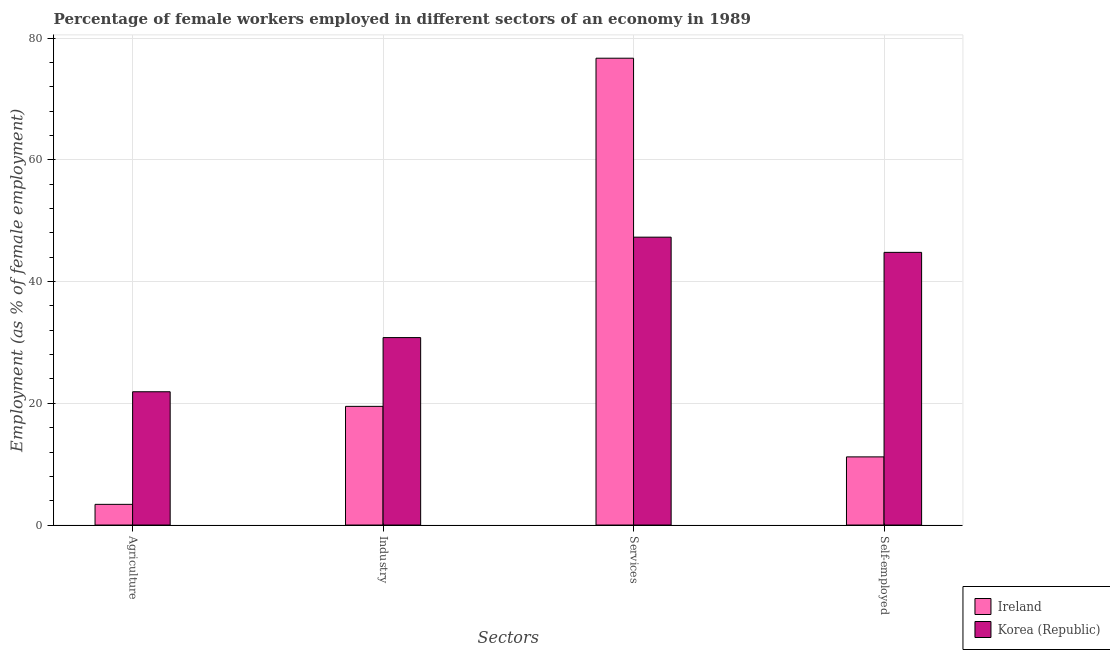How many different coloured bars are there?
Provide a short and direct response. 2. Are the number of bars per tick equal to the number of legend labels?
Your answer should be very brief. Yes. How many bars are there on the 4th tick from the left?
Your answer should be compact. 2. How many bars are there on the 3rd tick from the right?
Provide a short and direct response. 2. What is the label of the 4th group of bars from the left?
Your answer should be very brief. Self-employed. Across all countries, what is the maximum percentage of female workers in industry?
Your response must be concise. 30.8. In which country was the percentage of female workers in industry minimum?
Offer a terse response. Ireland. What is the total percentage of female workers in agriculture in the graph?
Provide a succinct answer. 25.3. What is the difference between the percentage of self employed female workers in Korea (Republic) and that in Ireland?
Your response must be concise. 33.6. What is the difference between the percentage of female workers in agriculture in Korea (Republic) and the percentage of female workers in services in Ireland?
Ensure brevity in your answer.  -54.8. What is the average percentage of female workers in industry per country?
Your answer should be very brief. 25.15. What is the difference between the percentage of female workers in services and percentage of female workers in agriculture in Ireland?
Provide a short and direct response. 73.3. What is the ratio of the percentage of female workers in industry in Ireland to that in Korea (Republic)?
Provide a succinct answer. 0.63. Is the difference between the percentage of female workers in agriculture in Korea (Republic) and Ireland greater than the difference between the percentage of female workers in industry in Korea (Republic) and Ireland?
Your answer should be compact. Yes. What is the difference between the highest and the second highest percentage of female workers in industry?
Offer a very short reply. 11.3. What is the difference between the highest and the lowest percentage of female workers in services?
Your answer should be very brief. 29.4. In how many countries, is the percentage of self employed female workers greater than the average percentage of self employed female workers taken over all countries?
Provide a short and direct response. 1. Is it the case that in every country, the sum of the percentage of self employed female workers and percentage of female workers in services is greater than the sum of percentage of female workers in industry and percentage of female workers in agriculture?
Offer a very short reply. Yes. What does the 1st bar from the right in Services represents?
Make the answer very short. Korea (Republic). Are all the bars in the graph horizontal?
Offer a terse response. No. What is the difference between two consecutive major ticks on the Y-axis?
Offer a terse response. 20. Does the graph contain any zero values?
Keep it short and to the point. No. Where does the legend appear in the graph?
Provide a succinct answer. Bottom right. How many legend labels are there?
Provide a succinct answer. 2. How are the legend labels stacked?
Offer a very short reply. Vertical. What is the title of the graph?
Provide a succinct answer. Percentage of female workers employed in different sectors of an economy in 1989. What is the label or title of the X-axis?
Provide a short and direct response. Sectors. What is the label or title of the Y-axis?
Give a very brief answer. Employment (as % of female employment). What is the Employment (as % of female employment) of Ireland in Agriculture?
Keep it short and to the point. 3.4. What is the Employment (as % of female employment) in Korea (Republic) in Agriculture?
Give a very brief answer. 21.9. What is the Employment (as % of female employment) of Korea (Republic) in Industry?
Offer a very short reply. 30.8. What is the Employment (as % of female employment) of Ireland in Services?
Offer a terse response. 76.7. What is the Employment (as % of female employment) in Korea (Republic) in Services?
Offer a very short reply. 47.3. What is the Employment (as % of female employment) in Ireland in Self-employed?
Your answer should be compact. 11.2. What is the Employment (as % of female employment) of Korea (Republic) in Self-employed?
Give a very brief answer. 44.8. Across all Sectors, what is the maximum Employment (as % of female employment) of Ireland?
Offer a terse response. 76.7. Across all Sectors, what is the maximum Employment (as % of female employment) of Korea (Republic)?
Ensure brevity in your answer.  47.3. Across all Sectors, what is the minimum Employment (as % of female employment) in Ireland?
Ensure brevity in your answer.  3.4. Across all Sectors, what is the minimum Employment (as % of female employment) of Korea (Republic)?
Your answer should be very brief. 21.9. What is the total Employment (as % of female employment) of Ireland in the graph?
Make the answer very short. 110.8. What is the total Employment (as % of female employment) in Korea (Republic) in the graph?
Offer a very short reply. 144.8. What is the difference between the Employment (as % of female employment) of Ireland in Agriculture and that in Industry?
Ensure brevity in your answer.  -16.1. What is the difference between the Employment (as % of female employment) in Korea (Republic) in Agriculture and that in Industry?
Ensure brevity in your answer.  -8.9. What is the difference between the Employment (as % of female employment) of Ireland in Agriculture and that in Services?
Provide a succinct answer. -73.3. What is the difference between the Employment (as % of female employment) of Korea (Republic) in Agriculture and that in Services?
Your response must be concise. -25.4. What is the difference between the Employment (as % of female employment) of Ireland in Agriculture and that in Self-employed?
Offer a terse response. -7.8. What is the difference between the Employment (as % of female employment) of Korea (Republic) in Agriculture and that in Self-employed?
Your answer should be very brief. -22.9. What is the difference between the Employment (as % of female employment) of Ireland in Industry and that in Services?
Your response must be concise. -57.2. What is the difference between the Employment (as % of female employment) of Korea (Republic) in Industry and that in Services?
Your answer should be very brief. -16.5. What is the difference between the Employment (as % of female employment) of Ireland in Services and that in Self-employed?
Provide a short and direct response. 65.5. What is the difference between the Employment (as % of female employment) of Korea (Republic) in Services and that in Self-employed?
Provide a succinct answer. 2.5. What is the difference between the Employment (as % of female employment) in Ireland in Agriculture and the Employment (as % of female employment) in Korea (Republic) in Industry?
Your answer should be very brief. -27.4. What is the difference between the Employment (as % of female employment) in Ireland in Agriculture and the Employment (as % of female employment) in Korea (Republic) in Services?
Your response must be concise. -43.9. What is the difference between the Employment (as % of female employment) in Ireland in Agriculture and the Employment (as % of female employment) in Korea (Republic) in Self-employed?
Make the answer very short. -41.4. What is the difference between the Employment (as % of female employment) in Ireland in Industry and the Employment (as % of female employment) in Korea (Republic) in Services?
Your answer should be compact. -27.8. What is the difference between the Employment (as % of female employment) of Ireland in Industry and the Employment (as % of female employment) of Korea (Republic) in Self-employed?
Make the answer very short. -25.3. What is the difference between the Employment (as % of female employment) of Ireland in Services and the Employment (as % of female employment) of Korea (Republic) in Self-employed?
Your answer should be very brief. 31.9. What is the average Employment (as % of female employment) in Ireland per Sectors?
Make the answer very short. 27.7. What is the average Employment (as % of female employment) in Korea (Republic) per Sectors?
Provide a short and direct response. 36.2. What is the difference between the Employment (as % of female employment) in Ireland and Employment (as % of female employment) in Korea (Republic) in Agriculture?
Provide a short and direct response. -18.5. What is the difference between the Employment (as % of female employment) in Ireland and Employment (as % of female employment) in Korea (Republic) in Industry?
Provide a succinct answer. -11.3. What is the difference between the Employment (as % of female employment) of Ireland and Employment (as % of female employment) of Korea (Republic) in Services?
Keep it short and to the point. 29.4. What is the difference between the Employment (as % of female employment) of Ireland and Employment (as % of female employment) of Korea (Republic) in Self-employed?
Provide a succinct answer. -33.6. What is the ratio of the Employment (as % of female employment) of Ireland in Agriculture to that in Industry?
Offer a terse response. 0.17. What is the ratio of the Employment (as % of female employment) in Korea (Republic) in Agriculture to that in Industry?
Keep it short and to the point. 0.71. What is the ratio of the Employment (as % of female employment) of Ireland in Agriculture to that in Services?
Keep it short and to the point. 0.04. What is the ratio of the Employment (as % of female employment) in Korea (Republic) in Agriculture to that in Services?
Your answer should be compact. 0.46. What is the ratio of the Employment (as % of female employment) of Ireland in Agriculture to that in Self-employed?
Offer a very short reply. 0.3. What is the ratio of the Employment (as % of female employment) of Korea (Republic) in Agriculture to that in Self-employed?
Ensure brevity in your answer.  0.49. What is the ratio of the Employment (as % of female employment) of Ireland in Industry to that in Services?
Your response must be concise. 0.25. What is the ratio of the Employment (as % of female employment) in Korea (Republic) in Industry to that in Services?
Ensure brevity in your answer.  0.65. What is the ratio of the Employment (as % of female employment) in Ireland in Industry to that in Self-employed?
Provide a short and direct response. 1.74. What is the ratio of the Employment (as % of female employment) in Korea (Republic) in Industry to that in Self-employed?
Give a very brief answer. 0.69. What is the ratio of the Employment (as % of female employment) of Ireland in Services to that in Self-employed?
Offer a very short reply. 6.85. What is the ratio of the Employment (as % of female employment) of Korea (Republic) in Services to that in Self-employed?
Give a very brief answer. 1.06. What is the difference between the highest and the second highest Employment (as % of female employment) of Ireland?
Offer a very short reply. 57.2. What is the difference between the highest and the lowest Employment (as % of female employment) of Ireland?
Give a very brief answer. 73.3. What is the difference between the highest and the lowest Employment (as % of female employment) in Korea (Republic)?
Offer a very short reply. 25.4. 